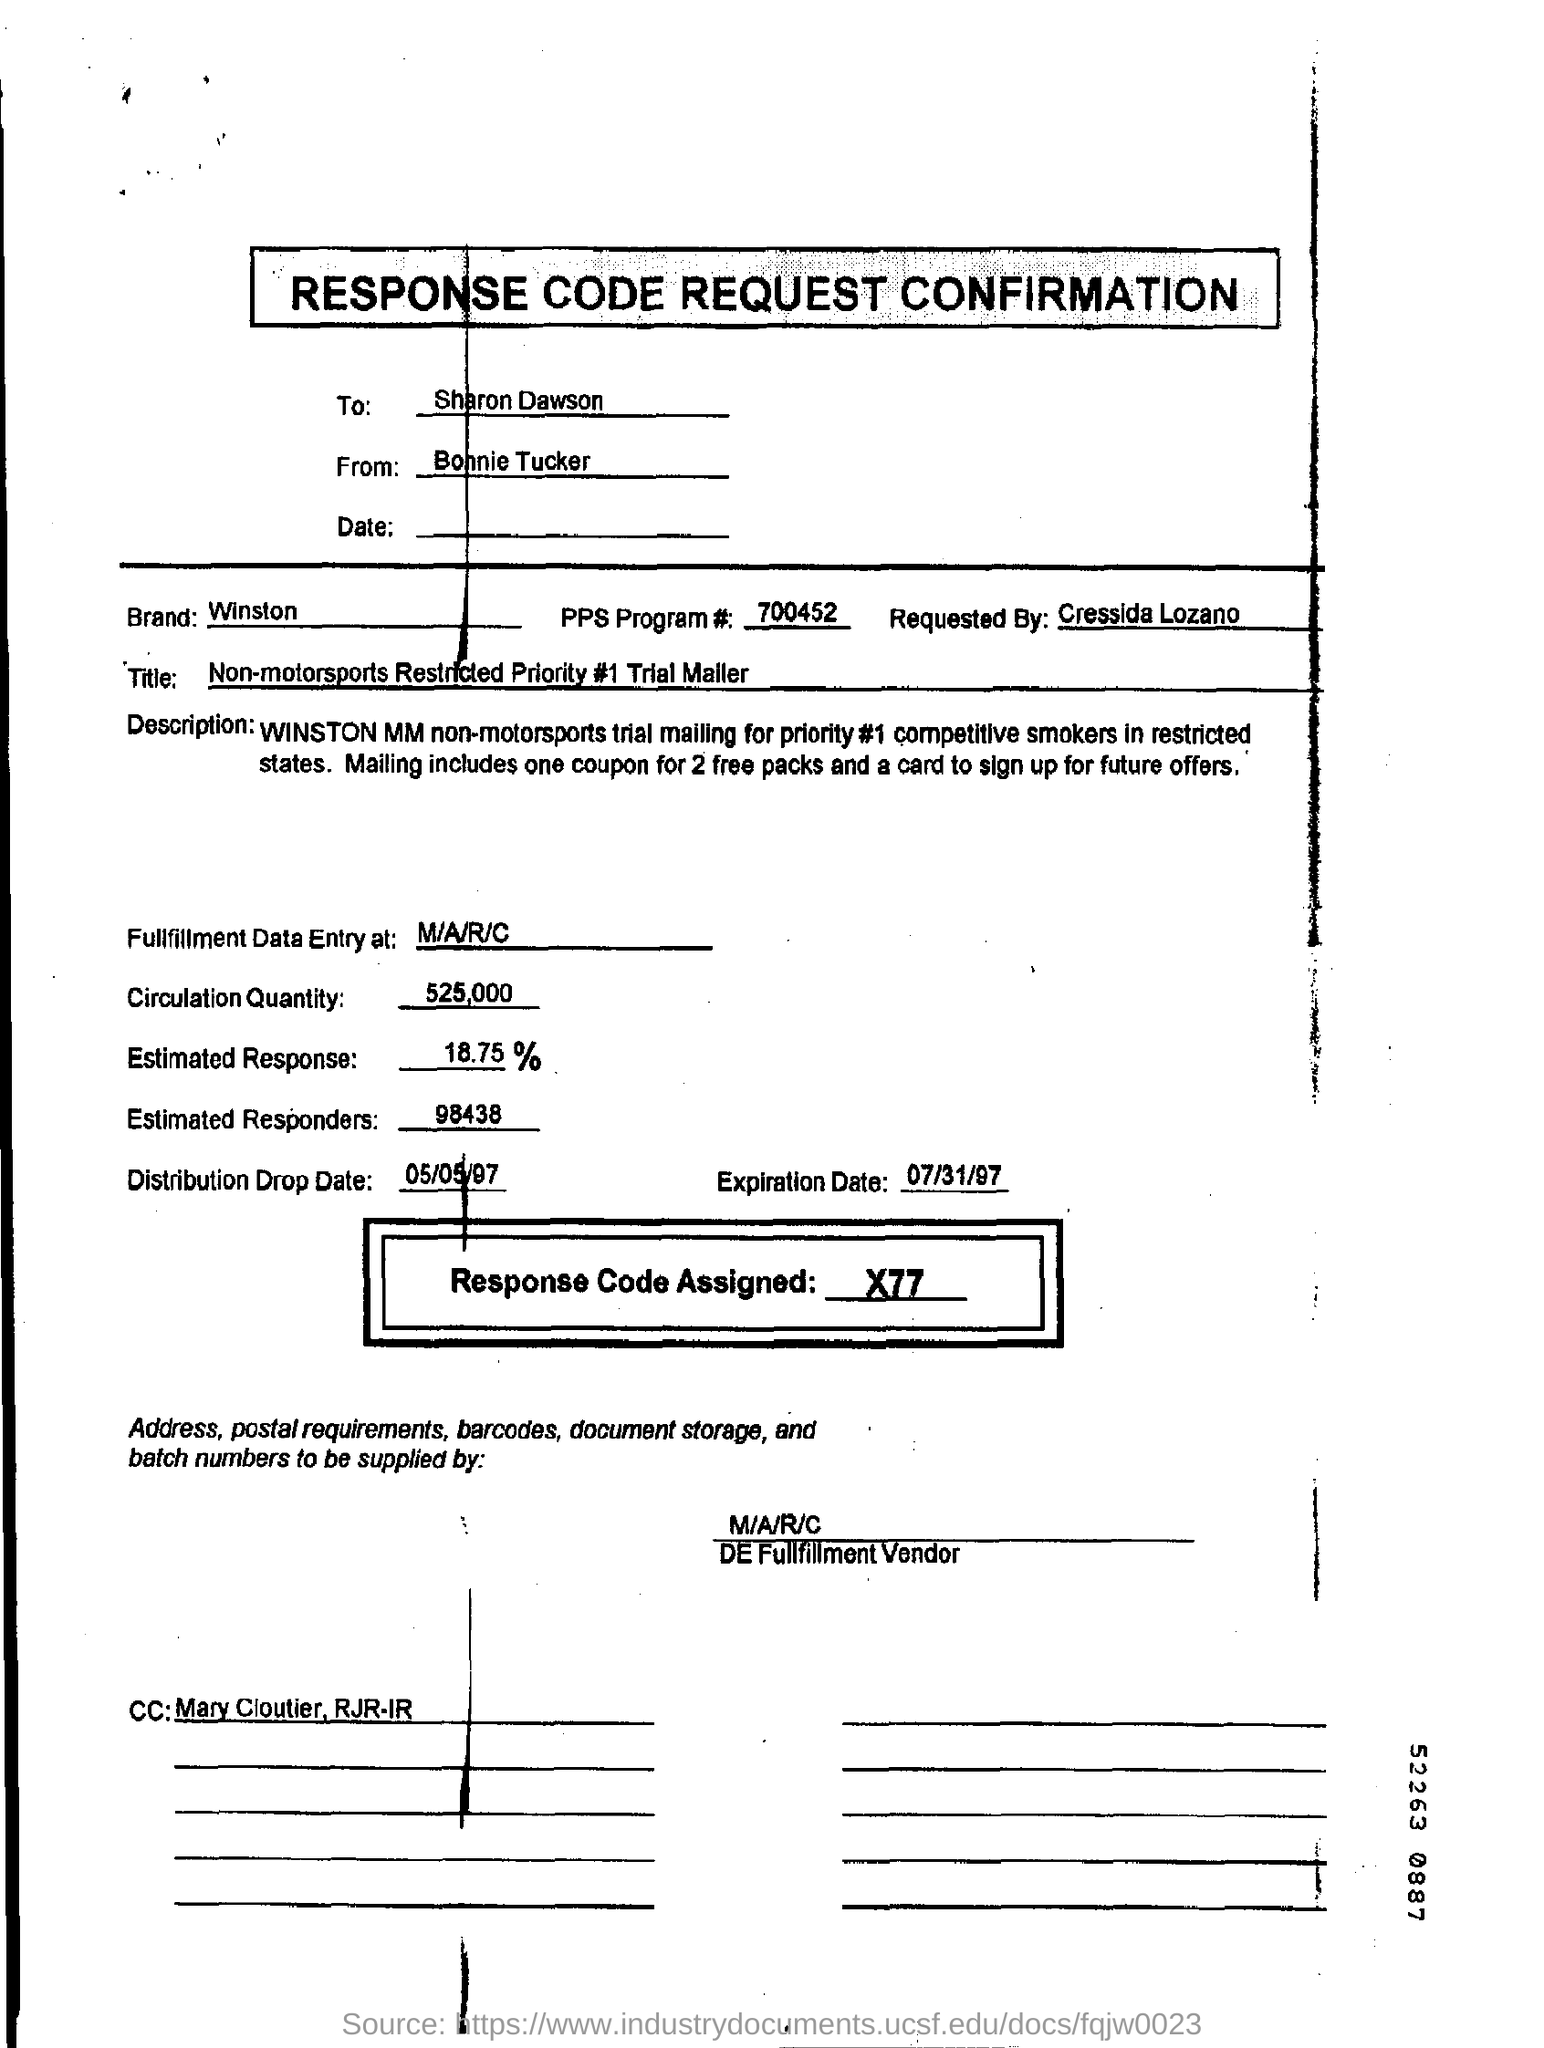What is the Distribution Drop Date?
Your answer should be compact. 05/05/97. To whom is this document addressed?
Your answer should be very brief. Sharon Dawson. 